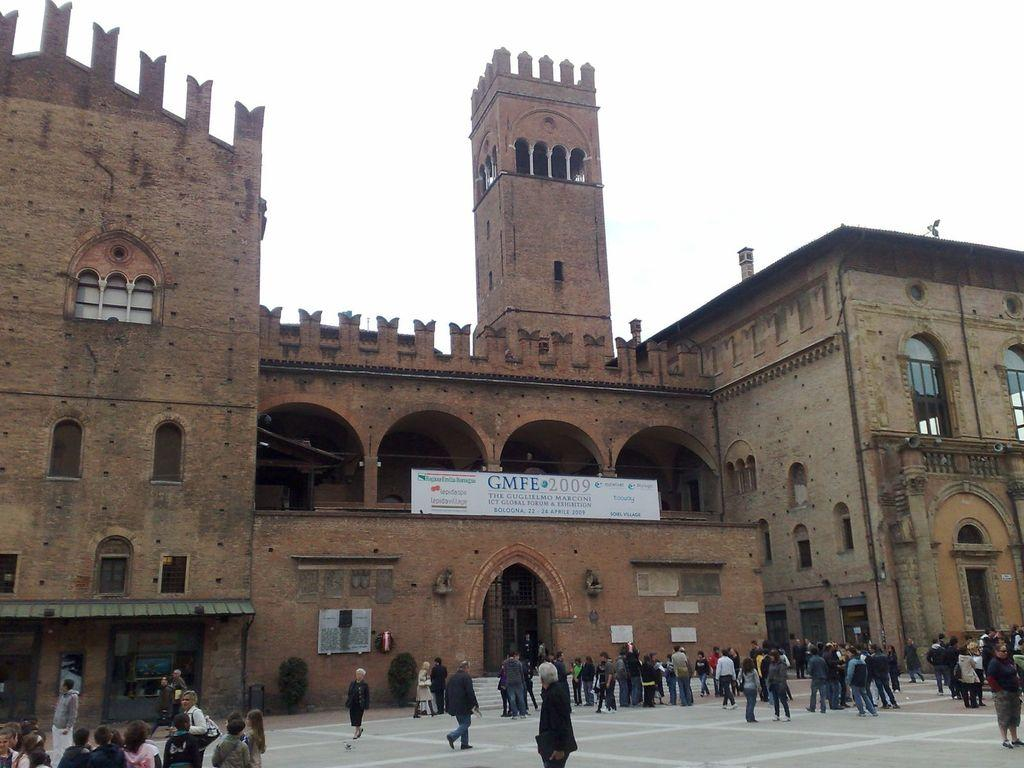What type of structures can be seen in the image? There are buildings in the image. What object is present in the image that is typically used for displaying information? There is a white color board in the image. What is the surface on which the people are standing in the image? The people are standing on the ground in the image. What type of vegetation is visible in the image? Trees are visible in the image. What is visible in the background of the image? The sky is visible in the background of the image. Can you tell me how many faces are visible on the control panel in the image? There is no control panel or faces present in the image. What type of range can be seen in the image? There is no range visible in the image; it features buildings, a white color board, people, trees, and the sky. 